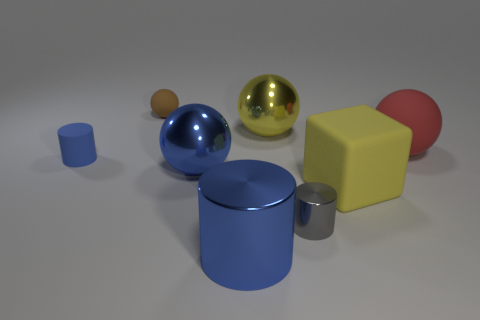Add 2 gray cylinders. How many objects exist? 10 Subtract all cubes. How many objects are left? 7 Subtract all large red blocks. Subtract all blue rubber things. How many objects are left? 7 Add 4 metal cylinders. How many metal cylinders are left? 6 Add 3 big yellow blocks. How many big yellow blocks exist? 4 Subtract 1 yellow blocks. How many objects are left? 7 